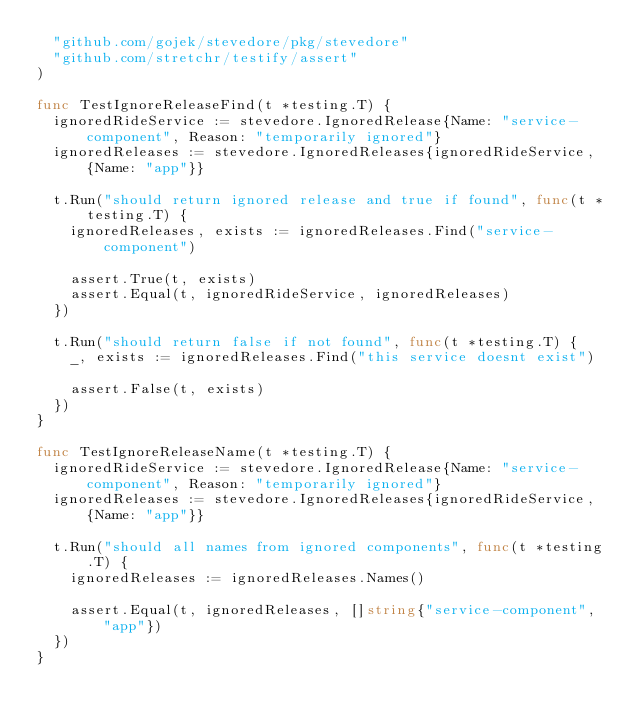Convert code to text. <code><loc_0><loc_0><loc_500><loc_500><_Go_>	"github.com/gojek/stevedore/pkg/stevedore"
	"github.com/stretchr/testify/assert"
)

func TestIgnoreReleaseFind(t *testing.T) {
	ignoredRideService := stevedore.IgnoredRelease{Name: "service-component", Reason: "temporarily ignored"}
	ignoredReleases := stevedore.IgnoredReleases{ignoredRideService, {Name: "app"}}

	t.Run("should return ignored release and true if found", func(t *testing.T) {
		ignoredReleases, exists := ignoredReleases.Find("service-component")

		assert.True(t, exists)
		assert.Equal(t, ignoredRideService, ignoredReleases)
	})

	t.Run("should return false if not found", func(t *testing.T) {
		_, exists := ignoredReleases.Find("this service doesnt exist")

		assert.False(t, exists)
	})
}

func TestIgnoreReleaseName(t *testing.T) {
	ignoredRideService := stevedore.IgnoredRelease{Name: "service-component", Reason: "temporarily ignored"}
	ignoredReleases := stevedore.IgnoredReleases{ignoredRideService, {Name: "app"}}

	t.Run("should all names from ignored components", func(t *testing.T) {
		ignoredReleases := ignoredReleases.Names()

		assert.Equal(t, ignoredReleases, []string{"service-component", "app"})
	})
}
</code> 